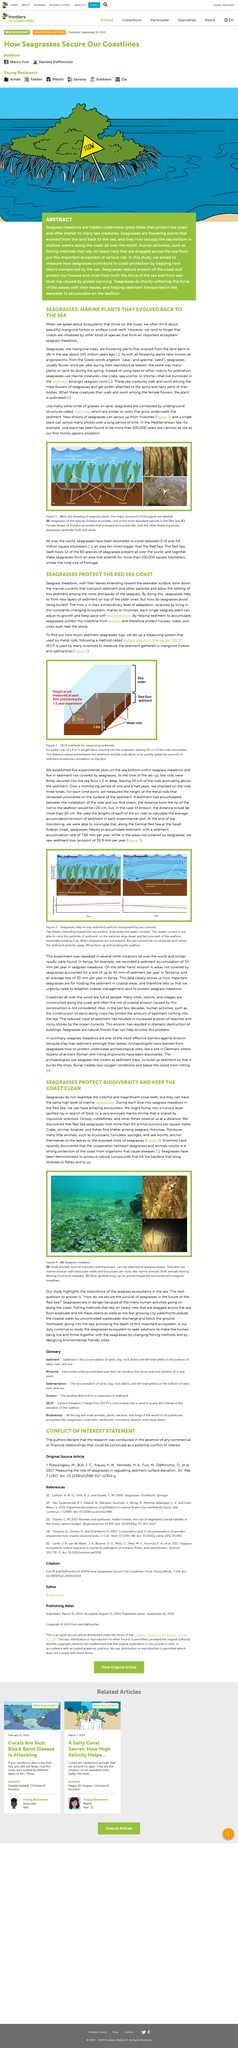Draw attention to some important aspects in this diagram. Seagrasses are connected through underground structures known as rhizomes. Five experimental plots were established on the sea bottom for the study. The method used to determine how much sediment seagrasses trap was a Surface Elevation Change Pin (SECP). The Central Red Sea is located along the coast of Saudi Arabia. Seagrass and mangrove trees are flowering plants that are mentioned in this paragraph. 